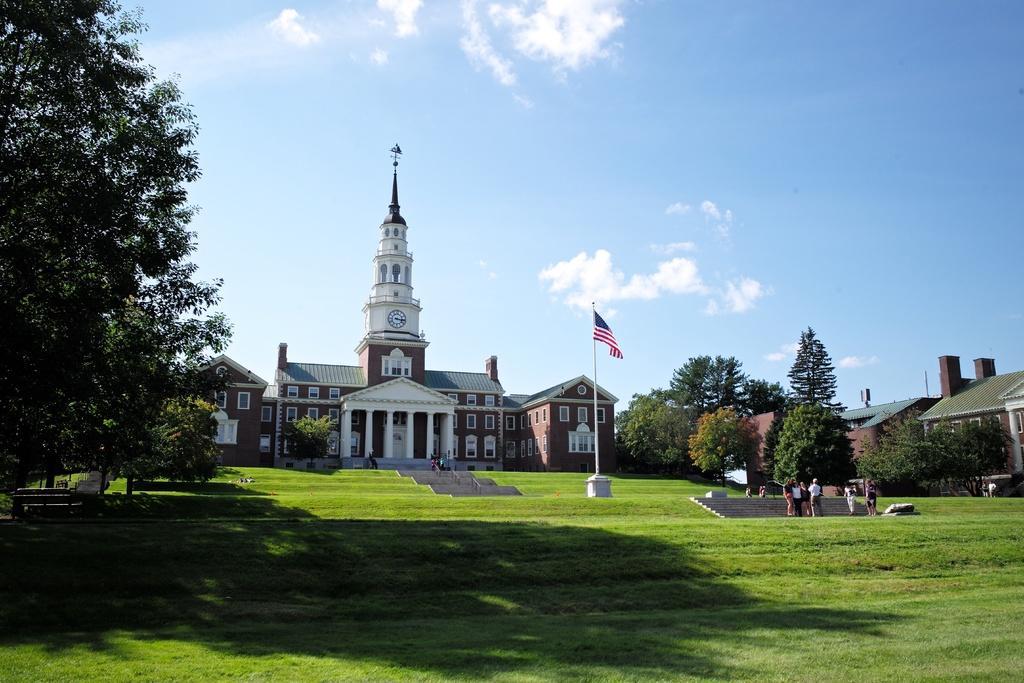In one or two sentences, can you explain what this image depicts? In this image I can see few people are standing on the ground. These people are wearing the different color dresses. To the side of these people I can see many trees. In the background I can see the building which is in brown and white color. I can also see the clock on the building. There is a flag in-front of the building. To the left I can see few more trees. In the background there are clouds and the blue sky. 